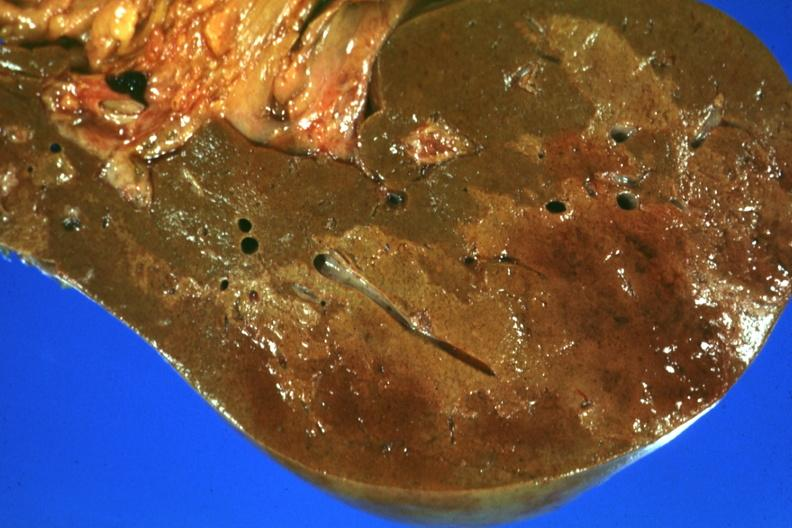does this image show frontal section with large patch of central infarction well seen?
Answer the question using a single word or phrase. Yes 